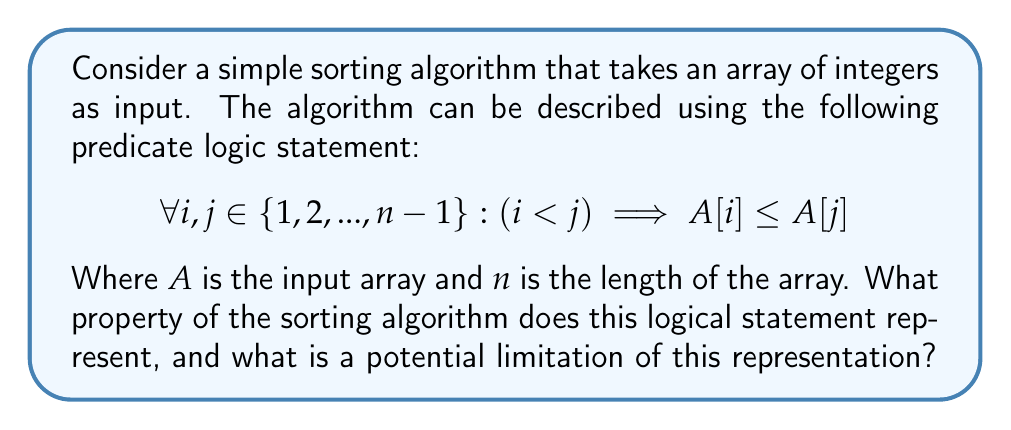Give your solution to this math problem. Let's break down the logical statement and analyze its meaning:

1. $\forall i, j \in \{1, 2, ..., n-1\}$: This means "for all $i$ and $j$ in the set of integers from 1 to $n-1$".

2. $(i < j) \implies A[i] \leq A[j]$: This is an implication. It states that if $i$ is less than $j$, then the element at index $i$ in the array $A$ is less than or equal to the element at index $j$.

3. The entire statement combines these parts, asserting that for any two indices in the array (where the first index is smaller than the second), the element at the first index is less than or equal to the element at the second index.

This logical statement represents the property of a sorted array in ascending order. It ensures that elements are in non-decreasing order throughout the array.

However, there is a limitation to this representation:

The statement only considers indices up to $n-1$, which means it doesn't explicitly include the last element of the array (at index $n$). While this doesn't affect the correctness of the statement for most cases, it could potentially miss comparing the second-to-last element with the last element.

A more comprehensive representation would use the range $\{1, 2, ..., n\}$ instead of $\{1, 2, ..., n-1\}$.

Additionally, this representation doesn't provide information about the algorithm itself, only about its desired output. It doesn't specify how the sorting is achieved, only what condition must be true after the sorting is complete.
Answer: The logical statement represents the property of a sorted array in ascending order. The limitation is that it doesn't explicitly include the last element of the array in its comparisons. 